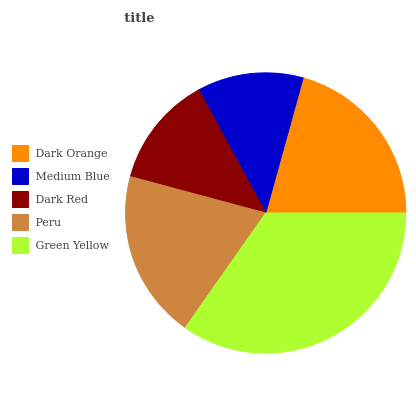Is Medium Blue the minimum?
Answer yes or no. Yes. Is Green Yellow the maximum?
Answer yes or no. Yes. Is Dark Red the minimum?
Answer yes or no. No. Is Dark Red the maximum?
Answer yes or no. No. Is Dark Red greater than Medium Blue?
Answer yes or no. Yes. Is Medium Blue less than Dark Red?
Answer yes or no. Yes. Is Medium Blue greater than Dark Red?
Answer yes or no. No. Is Dark Red less than Medium Blue?
Answer yes or no. No. Is Peru the high median?
Answer yes or no. Yes. Is Peru the low median?
Answer yes or no. Yes. Is Medium Blue the high median?
Answer yes or no. No. Is Green Yellow the low median?
Answer yes or no. No. 